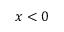Convert formula to latex. <formula><loc_0><loc_0><loc_500><loc_500>x < 0</formula> 